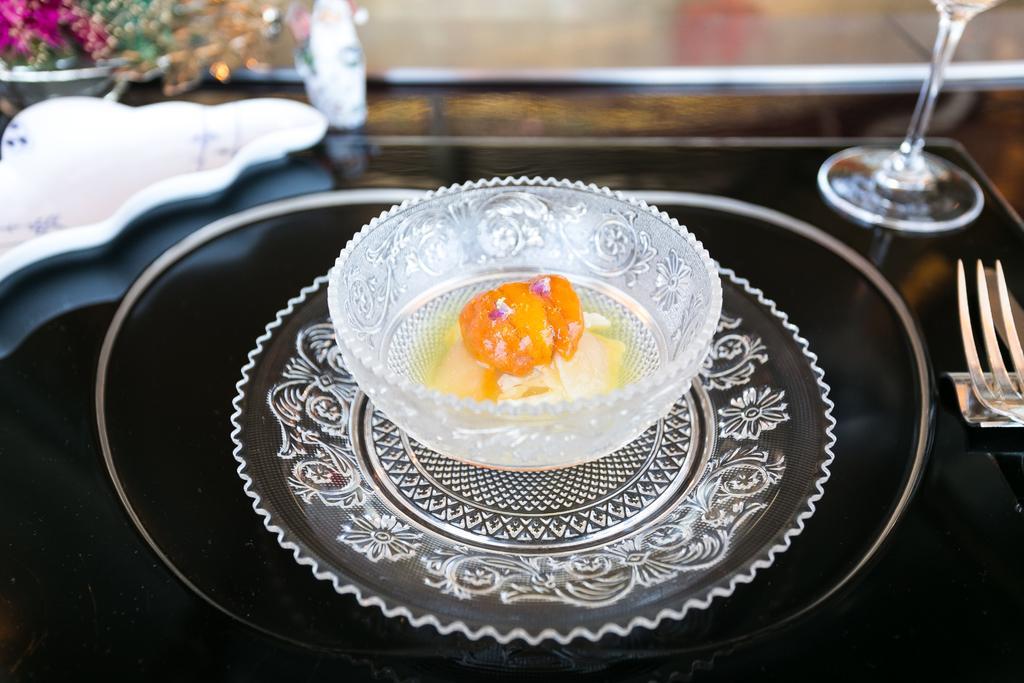Describe this image in one or two sentences. In this image there is a table and on top of the table there is a glass, fork and a bowl with the food item. 